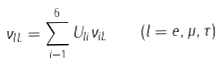Convert formula to latex. <formula><loc_0><loc_0><loc_500><loc_500>\nu _ { l L } = \sum _ { i = 1 } ^ { 6 } U _ { l i } \nu _ { i L } \quad ( l = e , \mu , \tau )</formula> 